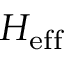Convert formula to latex. <formula><loc_0><loc_0><loc_500><loc_500>H _ { e f f }</formula> 